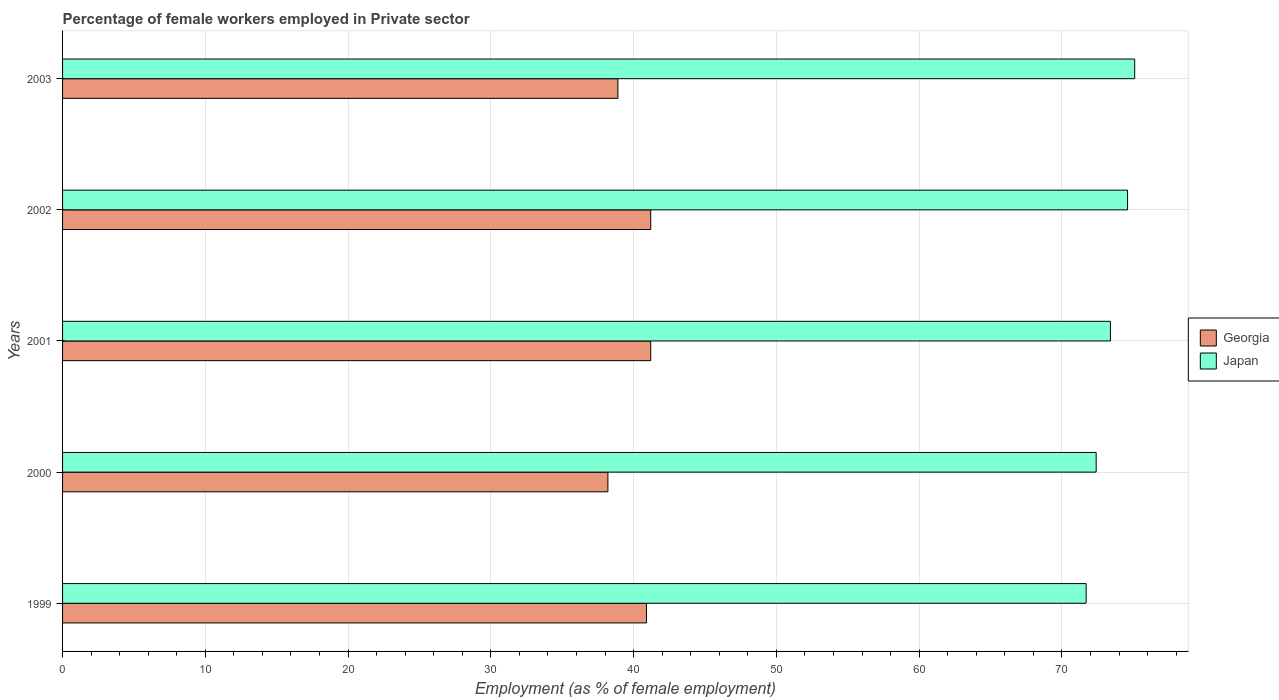How many different coloured bars are there?
Provide a succinct answer. 2. How many groups of bars are there?
Your response must be concise. 5. How many bars are there on the 4th tick from the top?
Ensure brevity in your answer.  2. What is the label of the 3rd group of bars from the top?
Offer a very short reply. 2001. In how many cases, is the number of bars for a given year not equal to the number of legend labels?
Your response must be concise. 0. What is the percentage of females employed in Private sector in Georgia in 2001?
Give a very brief answer. 41.2. Across all years, what is the maximum percentage of females employed in Private sector in Georgia?
Ensure brevity in your answer.  41.2. Across all years, what is the minimum percentage of females employed in Private sector in Japan?
Provide a succinct answer. 71.7. What is the total percentage of females employed in Private sector in Georgia in the graph?
Provide a short and direct response. 200.4. What is the difference between the percentage of females employed in Private sector in Georgia in 2000 and that in 2002?
Keep it short and to the point. -3. What is the difference between the percentage of females employed in Private sector in Georgia in 2000 and the percentage of females employed in Private sector in Japan in 1999?
Keep it short and to the point. -33.5. What is the average percentage of females employed in Private sector in Japan per year?
Provide a short and direct response. 73.44. In the year 2001, what is the difference between the percentage of females employed in Private sector in Japan and percentage of females employed in Private sector in Georgia?
Your response must be concise. 32.2. What is the ratio of the percentage of females employed in Private sector in Georgia in 1999 to that in 2002?
Your answer should be very brief. 0.99. In how many years, is the percentage of females employed in Private sector in Japan greater than the average percentage of females employed in Private sector in Japan taken over all years?
Provide a short and direct response. 2. What does the 2nd bar from the top in 2002 represents?
Give a very brief answer. Georgia. Are the values on the major ticks of X-axis written in scientific E-notation?
Give a very brief answer. No. Does the graph contain grids?
Keep it short and to the point. Yes. Where does the legend appear in the graph?
Provide a short and direct response. Center right. How many legend labels are there?
Your answer should be very brief. 2. How are the legend labels stacked?
Give a very brief answer. Vertical. What is the title of the graph?
Offer a terse response. Percentage of female workers employed in Private sector. Does "Switzerland" appear as one of the legend labels in the graph?
Give a very brief answer. No. What is the label or title of the X-axis?
Make the answer very short. Employment (as % of female employment). What is the label or title of the Y-axis?
Your answer should be compact. Years. What is the Employment (as % of female employment) in Georgia in 1999?
Your answer should be compact. 40.9. What is the Employment (as % of female employment) of Japan in 1999?
Your answer should be very brief. 71.7. What is the Employment (as % of female employment) of Georgia in 2000?
Your answer should be very brief. 38.2. What is the Employment (as % of female employment) in Japan in 2000?
Provide a succinct answer. 72.4. What is the Employment (as % of female employment) in Georgia in 2001?
Your answer should be very brief. 41.2. What is the Employment (as % of female employment) in Japan in 2001?
Your response must be concise. 73.4. What is the Employment (as % of female employment) of Georgia in 2002?
Give a very brief answer. 41.2. What is the Employment (as % of female employment) of Japan in 2002?
Provide a succinct answer. 74.6. What is the Employment (as % of female employment) of Georgia in 2003?
Your answer should be compact. 38.9. What is the Employment (as % of female employment) in Japan in 2003?
Make the answer very short. 75.1. Across all years, what is the maximum Employment (as % of female employment) of Georgia?
Your response must be concise. 41.2. Across all years, what is the maximum Employment (as % of female employment) in Japan?
Offer a terse response. 75.1. Across all years, what is the minimum Employment (as % of female employment) of Georgia?
Offer a very short reply. 38.2. Across all years, what is the minimum Employment (as % of female employment) of Japan?
Ensure brevity in your answer.  71.7. What is the total Employment (as % of female employment) of Georgia in the graph?
Ensure brevity in your answer.  200.4. What is the total Employment (as % of female employment) in Japan in the graph?
Keep it short and to the point. 367.2. What is the difference between the Employment (as % of female employment) of Georgia in 1999 and that in 2000?
Provide a succinct answer. 2.7. What is the difference between the Employment (as % of female employment) of Japan in 1999 and that in 2001?
Offer a very short reply. -1.7. What is the difference between the Employment (as % of female employment) of Japan in 1999 and that in 2003?
Provide a short and direct response. -3.4. What is the difference between the Employment (as % of female employment) of Georgia in 2000 and that in 2001?
Make the answer very short. -3. What is the difference between the Employment (as % of female employment) of Japan in 2000 and that in 2002?
Keep it short and to the point. -2.2. What is the difference between the Employment (as % of female employment) in Georgia in 2000 and that in 2003?
Offer a very short reply. -0.7. What is the difference between the Employment (as % of female employment) of Georgia in 2001 and that in 2002?
Give a very brief answer. 0. What is the difference between the Employment (as % of female employment) of Georgia in 2002 and that in 2003?
Your response must be concise. 2.3. What is the difference between the Employment (as % of female employment) of Japan in 2002 and that in 2003?
Keep it short and to the point. -0.5. What is the difference between the Employment (as % of female employment) in Georgia in 1999 and the Employment (as % of female employment) in Japan in 2000?
Offer a terse response. -31.5. What is the difference between the Employment (as % of female employment) of Georgia in 1999 and the Employment (as % of female employment) of Japan in 2001?
Give a very brief answer. -32.5. What is the difference between the Employment (as % of female employment) of Georgia in 1999 and the Employment (as % of female employment) of Japan in 2002?
Provide a succinct answer. -33.7. What is the difference between the Employment (as % of female employment) of Georgia in 1999 and the Employment (as % of female employment) of Japan in 2003?
Offer a terse response. -34.2. What is the difference between the Employment (as % of female employment) in Georgia in 2000 and the Employment (as % of female employment) in Japan in 2001?
Provide a succinct answer. -35.2. What is the difference between the Employment (as % of female employment) of Georgia in 2000 and the Employment (as % of female employment) of Japan in 2002?
Provide a short and direct response. -36.4. What is the difference between the Employment (as % of female employment) in Georgia in 2000 and the Employment (as % of female employment) in Japan in 2003?
Offer a very short reply. -36.9. What is the difference between the Employment (as % of female employment) in Georgia in 2001 and the Employment (as % of female employment) in Japan in 2002?
Provide a short and direct response. -33.4. What is the difference between the Employment (as % of female employment) in Georgia in 2001 and the Employment (as % of female employment) in Japan in 2003?
Keep it short and to the point. -33.9. What is the difference between the Employment (as % of female employment) in Georgia in 2002 and the Employment (as % of female employment) in Japan in 2003?
Give a very brief answer. -33.9. What is the average Employment (as % of female employment) in Georgia per year?
Offer a very short reply. 40.08. What is the average Employment (as % of female employment) in Japan per year?
Ensure brevity in your answer.  73.44. In the year 1999, what is the difference between the Employment (as % of female employment) of Georgia and Employment (as % of female employment) of Japan?
Your answer should be compact. -30.8. In the year 2000, what is the difference between the Employment (as % of female employment) in Georgia and Employment (as % of female employment) in Japan?
Give a very brief answer. -34.2. In the year 2001, what is the difference between the Employment (as % of female employment) in Georgia and Employment (as % of female employment) in Japan?
Your response must be concise. -32.2. In the year 2002, what is the difference between the Employment (as % of female employment) in Georgia and Employment (as % of female employment) in Japan?
Provide a short and direct response. -33.4. In the year 2003, what is the difference between the Employment (as % of female employment) of Georgia and Employment (as % of female employment) of Japan?
Offer a very short reply. -36.2. What is the ratio of the Employment (as % of female employment) in Georgia in 1999 to that in 2000?
Keep it short and to the point. 1.07. What is the ratio of the Employment (as % of female employment) in Japan in 1999 to that in 2000?
Give a very brief answer. 0.99. What is the ratio of the Employment (as % of female employment) of Georgia in 1999 to that in 2001?
Make the answer very short. 0.99. What is the ratio of the Employment (as % of female employment) of Japan in 1999 to that in 2001?
Your answer should be compact. 0.98. What is the ratio of the Employment (as % of female employment) of Japan in 1999 to that in 2002?
Provide a succinct answer. 0.96. What is the ratio of the Employment (as % of female employment) of Georgia in 1999 to that in 2003?
Make the answer very short. 1.05. What is the ratio of the Employment (as % of female employment) of Japan in 1999 to that in 2003?
Your answer should be very brief. 0.95. What is the ratio of the Employment (as % of female employment) of Georgia in 2000 to that in 2001?
Provide a succinct answer. 0.93. What is the ratio of the Employment (as % of female employment) of Japan in 2000 to that in 2001?
Make the answer very short. 0.99. What is the ratio of the Employment (as % of female employment) in Georgia in 2000 to that in 2002?
Offer a terse response. 0.93. What is the ratio of the Employment (as % of female employment) of Japan in 2000 to that in 2002?
Your answer should be compact. 0.97. What is the ratio of the Employment (as % of female employment) in Japan in 2000 to that in 2003?
Make the answer very short. 0.96. What is the ratio of the Employment (as % of female employment) in Georgia in 2001 to that in 2002?
Your response must be concise. 1. What is the ratio of the Employment (as % of female employment) of Japan in 2001 to that in 2002?
Offer a very short reply. 0.98. What is the ratio of the Employment (as % of female employment) of Georgia in 2001 to that in 2003?
Offer a terse response. 1.06. What is the ratio of the Employment (as % of female employment) of Japan in 2001 to that in 2003?
Offer a terse response. 0.98. What is the ratio of the Employment (as % of female employment) of Georgia in 2002 to that in 2003?
Your answer should be compact. 1.06. What is the ratio of the Employment (as % of female employment) of Japan in 2002 to that in 2003?
Ensure brevity in your answer.  0.99. What is the difference between the highest and the second highest Employment (as % of female employment) in Georgia?
Ensure brevity in your answer.  0. 